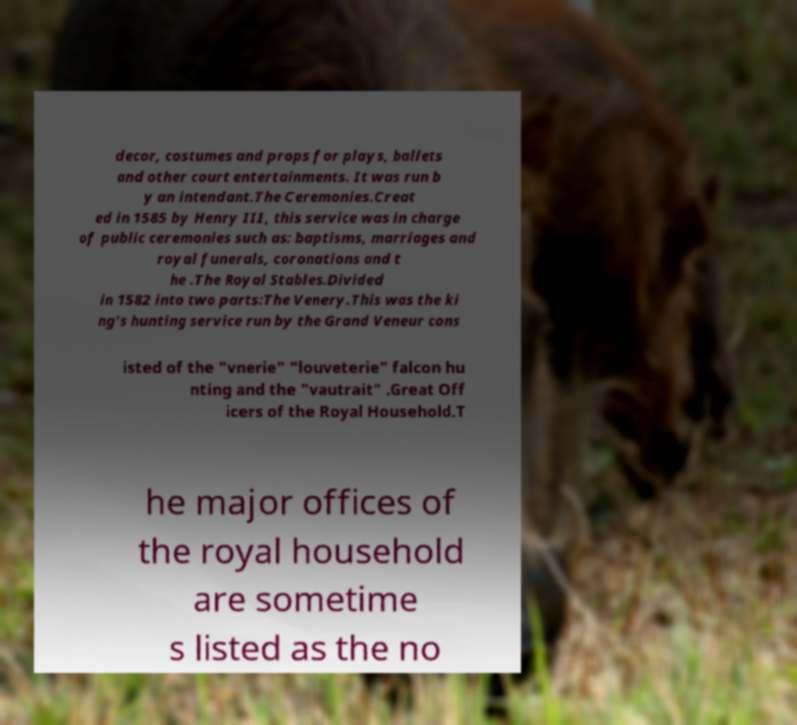Could you assist in decoding the text presented in this image and type it out clearly? decor, costumes and props for plays, ballets and other court entertainments. It was run b y an intendant.The Ceremonies.Creat ed in 1585 by Henry III, this service was in charge of public ceremonies such as: baptisms, marriages and royal funerals, coronations and t he .The Royal Stables.Divided in 1582 into two parts:The Venery.This was the ki ng's hunting service run by the Grand Veneur cons isted of the "vnerie" "louveterie" falcon hu nting and the "vautrait" .Great Off icers of the Royal Household.T he major offices of the royal household are sometime s listed as the no 